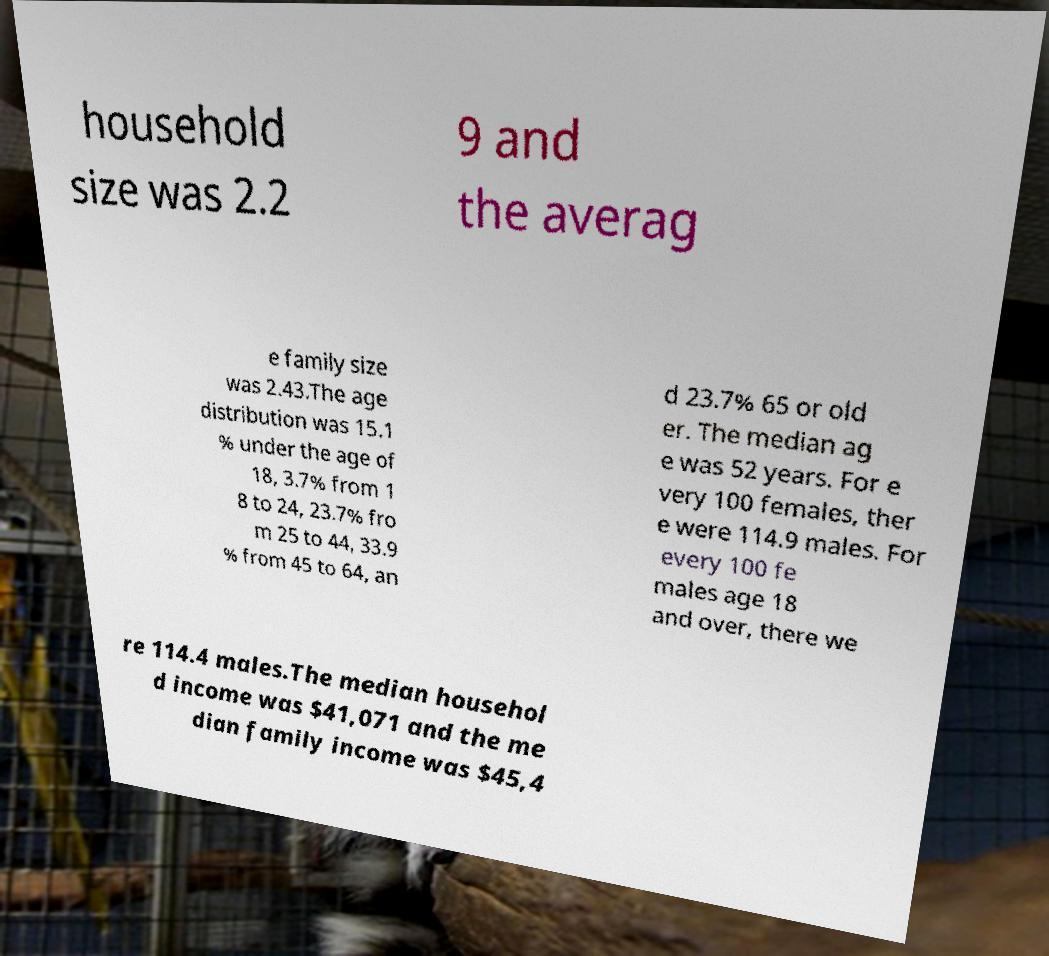There's text embedded in this image that I need extracted. Can you transcribe it verbatim? household size was 2.2 9 and the averag e family size was 2.43.The age distribution was 15.1 % under the age of 18, 3.7% from 1 8 to 24, 23.7% fro m 25 to 44, 33.9 % from 45 to 64, an d 23.7% 65 or old er. The median ag e was 52 years. For e very 100 females, ther e were 114.9 males. For every 100 fe males age 18 and over, there we re 114.4 males.The median househol d income was $41,071 and the me dian family income was $45,4 